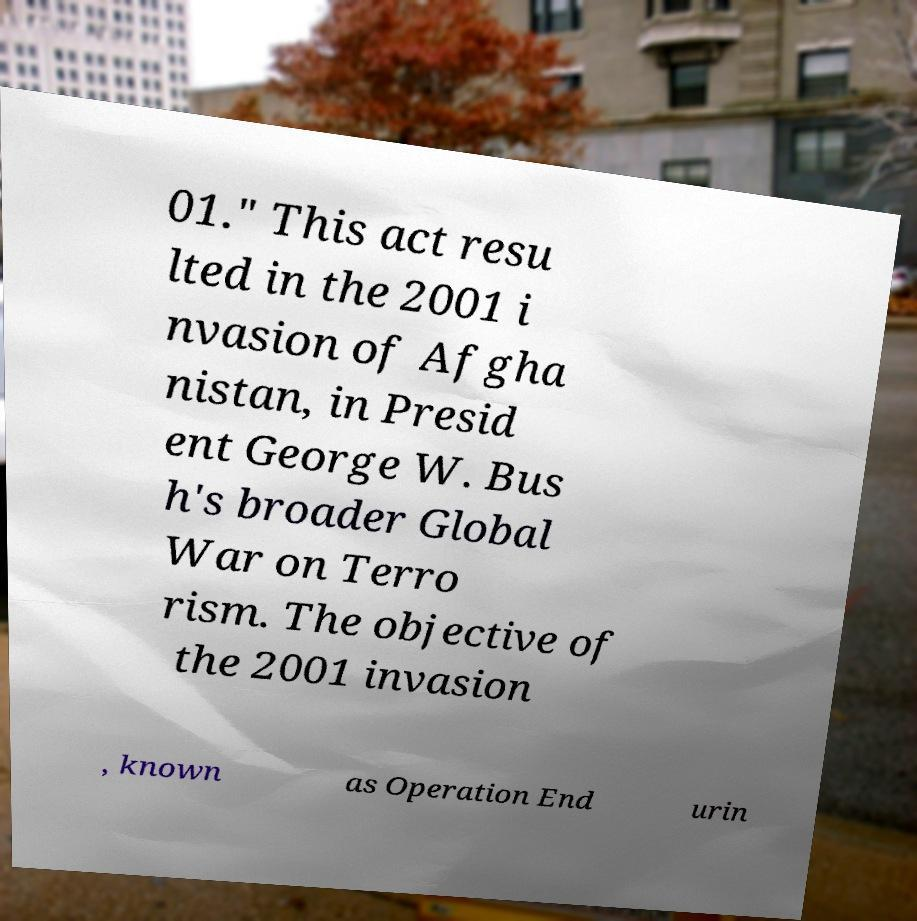What messages or text are displayed in this image? I need them in a readable, typed format. 01." This act resu lted in the 2001 i nvasion of Afgha nistan, in Presid ent George W. Bus h's broader Global War on Terro rism. The objective of the 2001 invasion , known as Operation End urin 